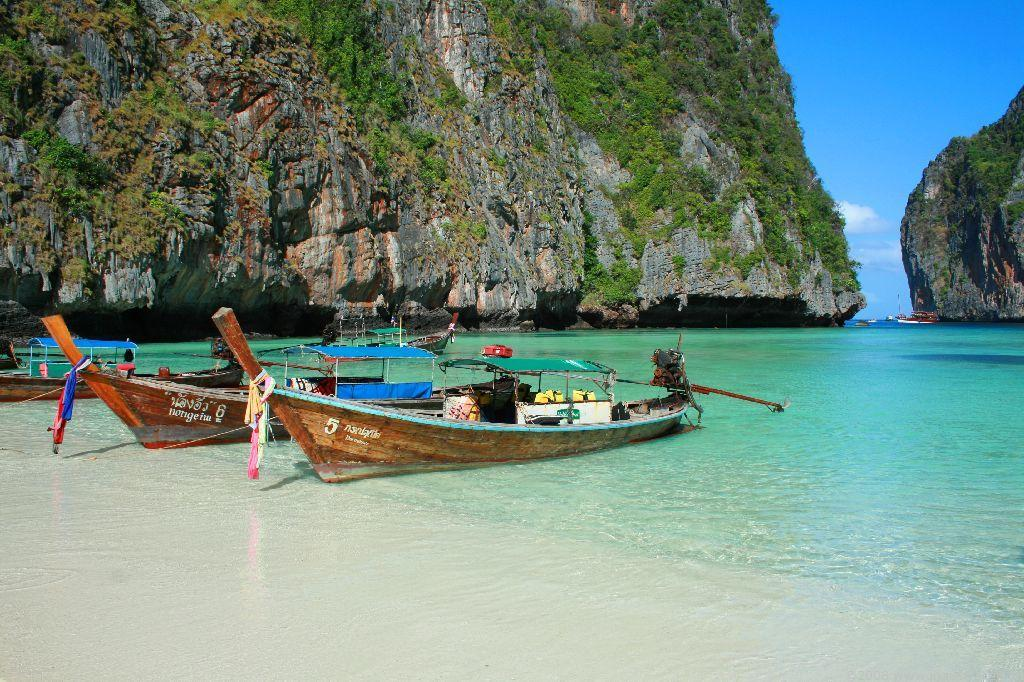<image>
Write a terse but informative summary of the picture. Boats 5 and 6 are resting in shallow water in the beautiful bay. 